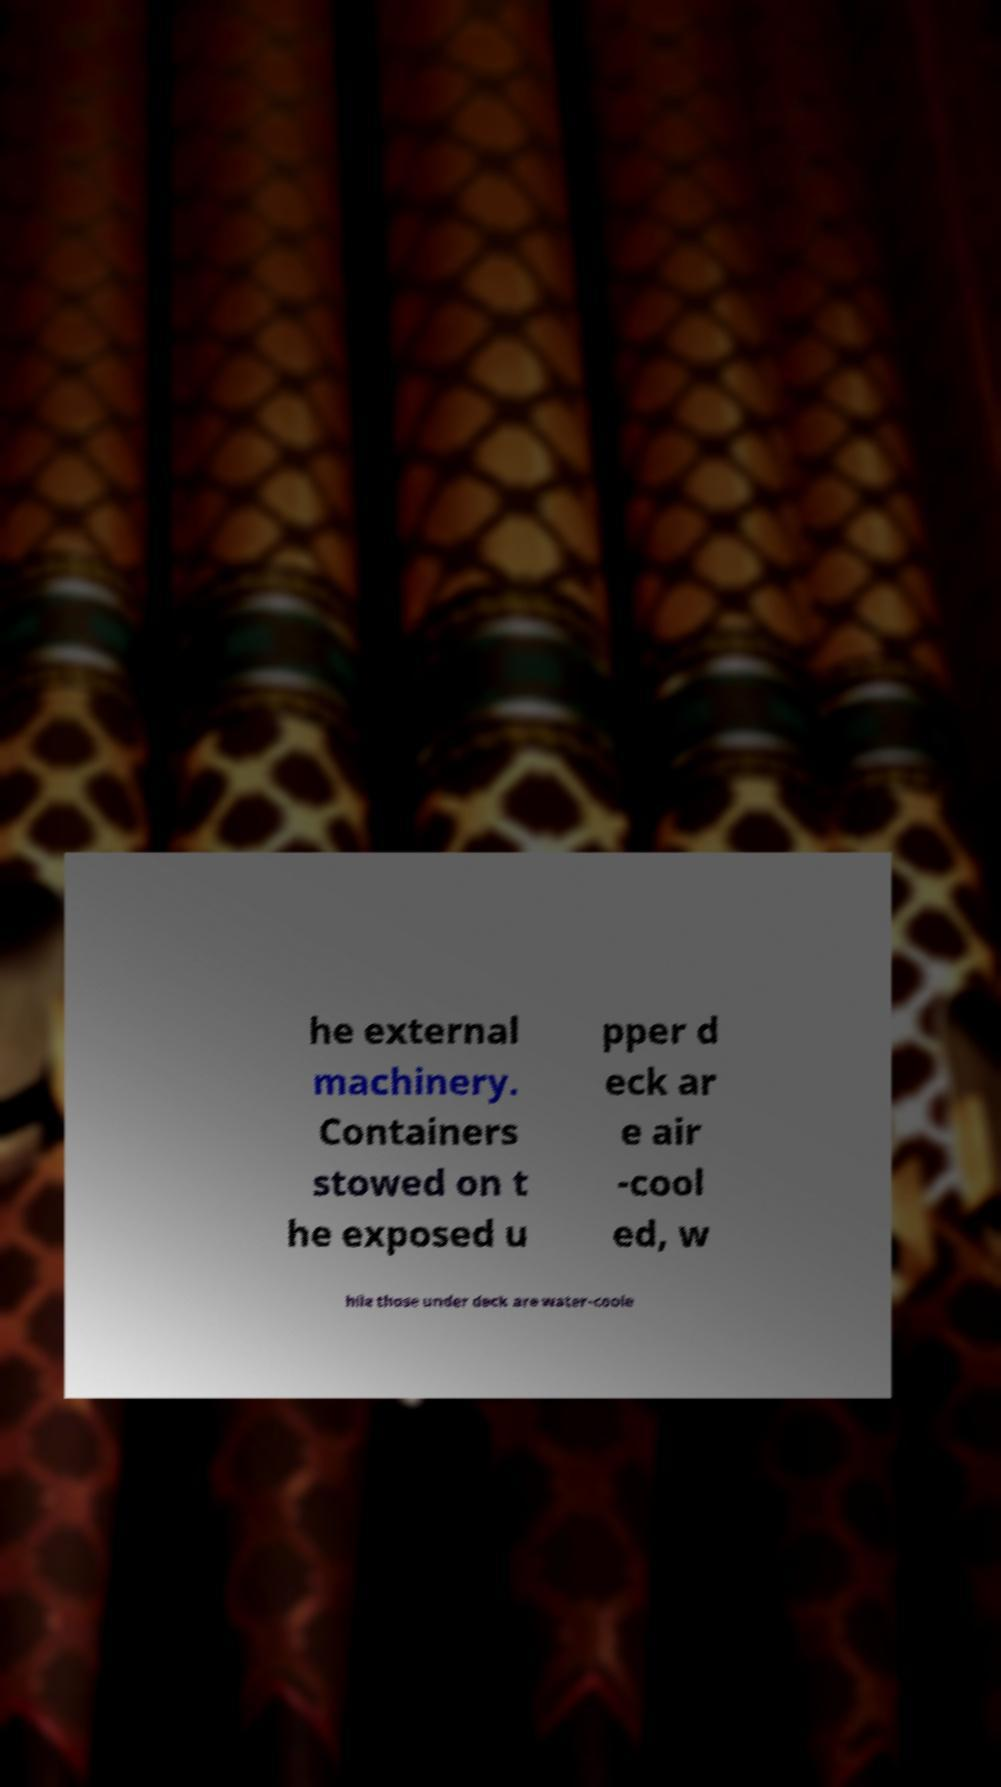For documentation purposes, I need the text within this image transcribed. Could you provide that? he external machinery. Containers stowed on t he exposed u pper d eck ar e air -cool ed, w hile those under deck are water-coole 